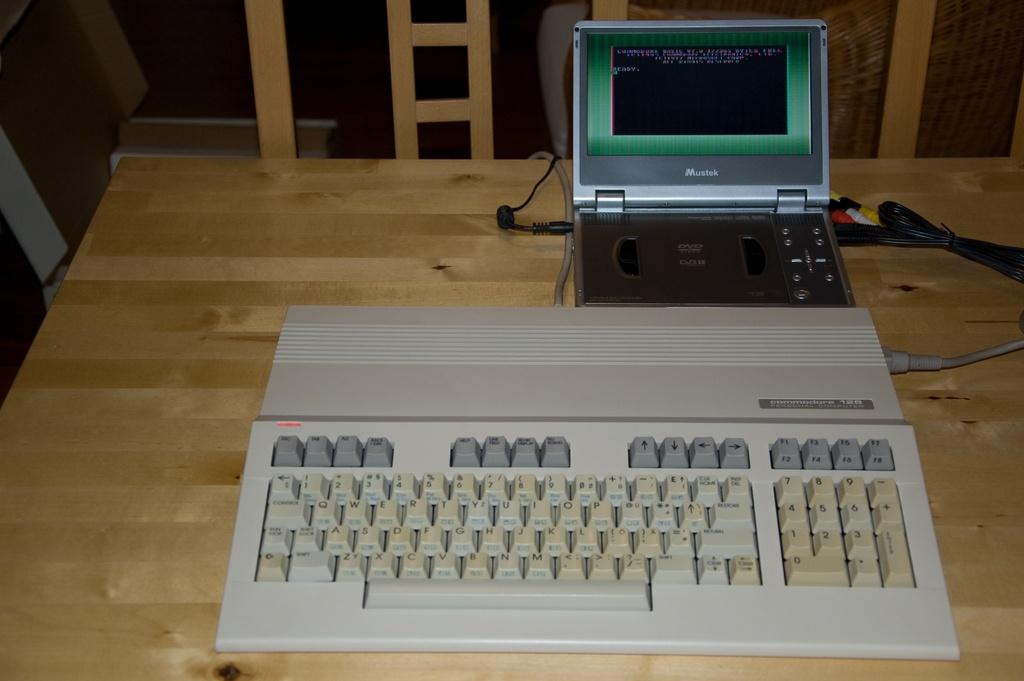What type of input device is visible in the image? There is a keyboard in the image. What color is the keyboard? The keyboard is white in color. What can be seen on the right side of the keyboard? There is an electronic device on the right side of the keyboard. What type of coal is being used by the farmer in the image? There is no farmer or coal present in the image; it features a white keyboard and an electronic device. 